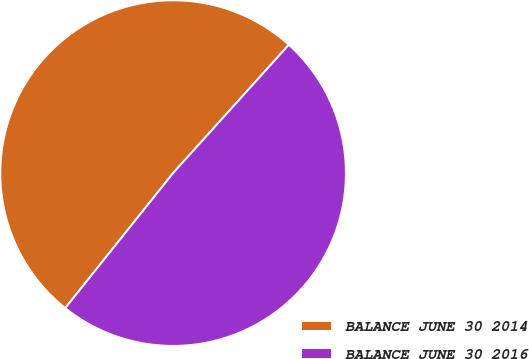Convert chart to OTSL. <chart><loc_0><loc_0><loc_500><loc_500><pie_chart><fcel>BALANCE JUNE 30 2014<fcel>BALANCE JUNE 30 2016<nl><fcel>50.95%<fcel>49.05%<nl></chart> 